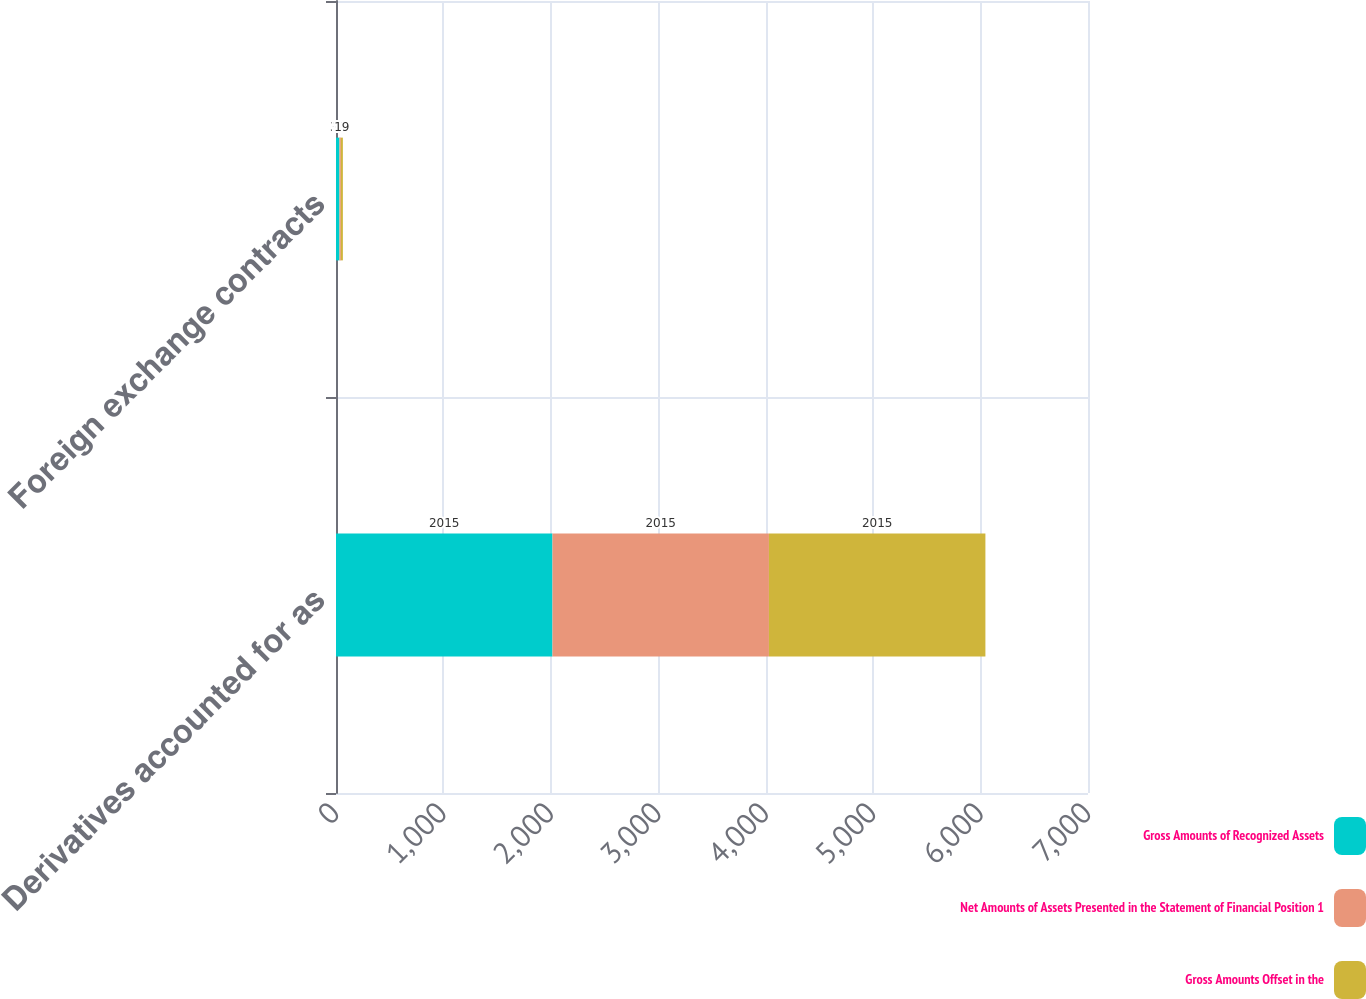Convert chart. <chart><loc_0><loc_0><loc_500><loc_500><stacked_bar_chart><ecel><fcel>Derivatives accounted for as<fcel>Foreign exchange contracts<nl><fcel>Gross Amounts of Recognized Assets<fcel>2015<fcel>32<nl><fcel>Net Amounts of Assets Presented in the Statement of Financial Position 1<fcel>2015<fcel>13<nl><fcel>Gross Amounts Offset in the<fcel>2015<fcel>19<nl></chart> 